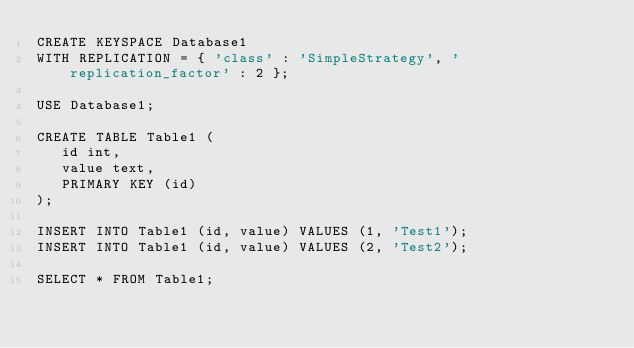<code> <loc_0><loc_0><loc_500><loc_500><_SQL_>CREATE KEYSPACE Database1 
WITH REPLICATION = { 'class' : 'SimpleStrategy', 'replication_factor' : 2 };

USE Database1;

CREATE TABLE Table1 (
   id int,
   value text,
   PRIMARY KEY (id)
);

INSERT INTO Table1 (id, value) VALUES (1, 'Test1');
INSERT INTO Table1 (id, value) VALUES (2, 'Test2');

SELECT * FROM Table1;</code> 